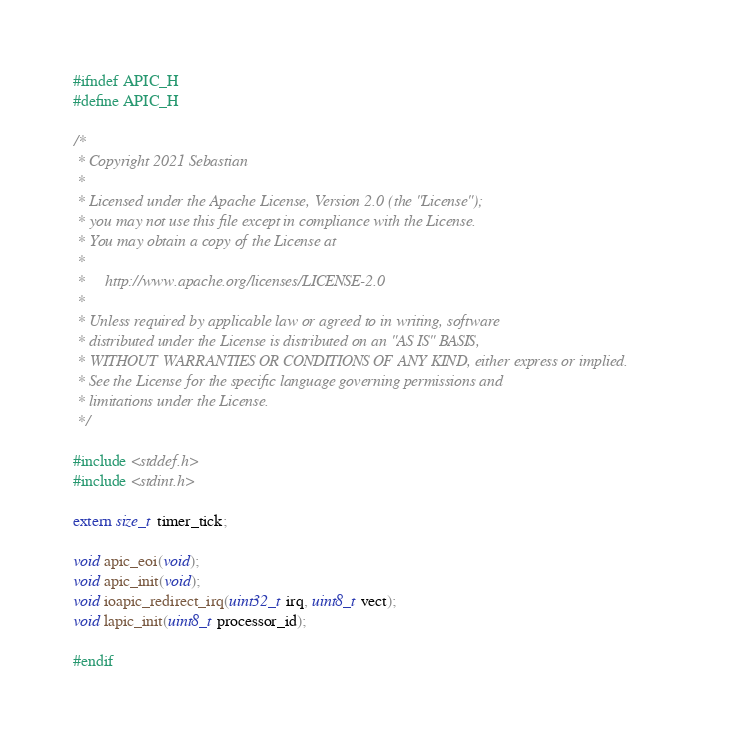<code> <loc_0><loc_0><loc_500><loc_500><_C_>#ifndef APIC_H
#define APIC_H

/*
 * Copyright 2021 Sebastian
 *
 * Licensed under the Apache License, Version 2.0 (the "License");
 * you may not use this file except in compliance with the License.
 * You may obtain a copy of the License at
 *
 *     http://www.apache.org/licenses/LICENSE-2.0
 *
 * Unless required by applicable law or agreed to in writing, software
 * distributed under the License is distributed on an "AS IS" BASIS,
 * WITHOUT WARRANTIES OR CONDITIONS OF ANY KIND, either express or implied.
 * See the License for the specific language governing permissions and
 * limitations under the License.
 */

#include <stddef.h>
#include <stdint.h>

extern size_t timer_tick;

void apic_eoi(void);
void apic_init(void);
void ioapic_redirect_irq(uint32_t irq, uint8_t vect);
void lapic_init(uint8_t processor_id);

#endif
</code> 